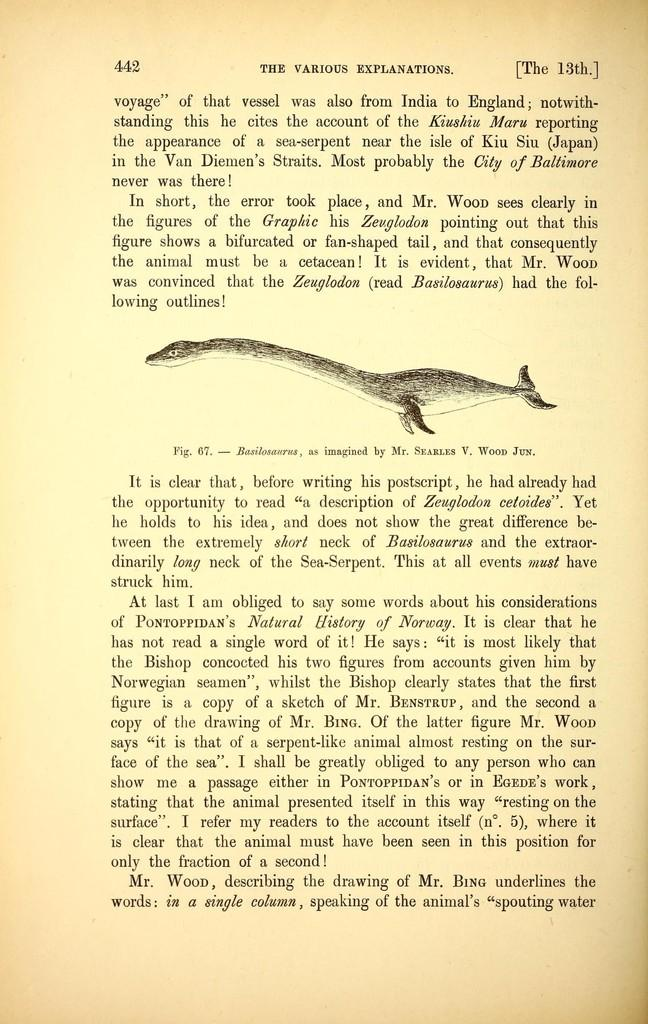What type of image can be seen on the page? There is an animal depicted on the page. What else is present on the page besides the image? There is text present on the page. How many sisters does the horse have in the image? There is no horse present in the image, and therefore no information about any sisters. 